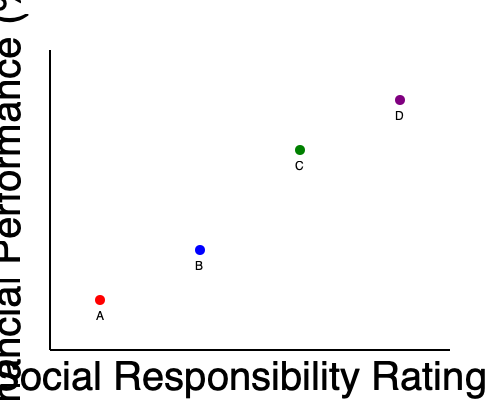As a Catholic business owner concerned with socially responsible investing, which company would you consider the best investment option based on the scatter plot showing financial performance versus social responsibility ratings? To determine the best investment option for a Catholic business owner focused on socially responsible investing, we need to consider both financial performance and social responsibility ratings. Let's analyze the scatter plot step-by-step:

1. Identify the axes:
   - X-axis: Social Responsibility Rating (increases from left to right)
   - Y-axis: Financial Performance (increases from bottom to top)

2. Locate each company on the plot:
   - Company A: Low social responsibility, low financial performance
   - Company B: Moderate social responsibility, moderate financial performance
   - Company C: High social responsibility, high financial performance
   - Company D: Very high social responsibility, very high financial performance

3. Consider the Catholic business owner's priorities:
   - Seeking guidance on investing in socially responsible companies
   - Also interested in financial performance for business success

4. Evaluate each company:
   - Company A: Least desirable due to low social responsibility and low financial performance
   - Company B: Moderate option, but not optimal
   - Company C: Strong contender with high ratings in both aspects
   - Company D: Best option with the highest social responsibility and financial performance

5. Conclusion:
   Company D offers the best balance of social responsibility and financial performance, aligning with Catholic values and business objectives.
Answer: Company D 